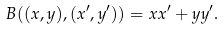Convert formula to latex. <formula><loc_0><loc_0><loc_500><loc_500>B ( ( x , y ) , ( x ^ { \prime } , y ^ { \prime } ) ) = x x ^ { \prime } + y y ^ { \prime } .</formula> 